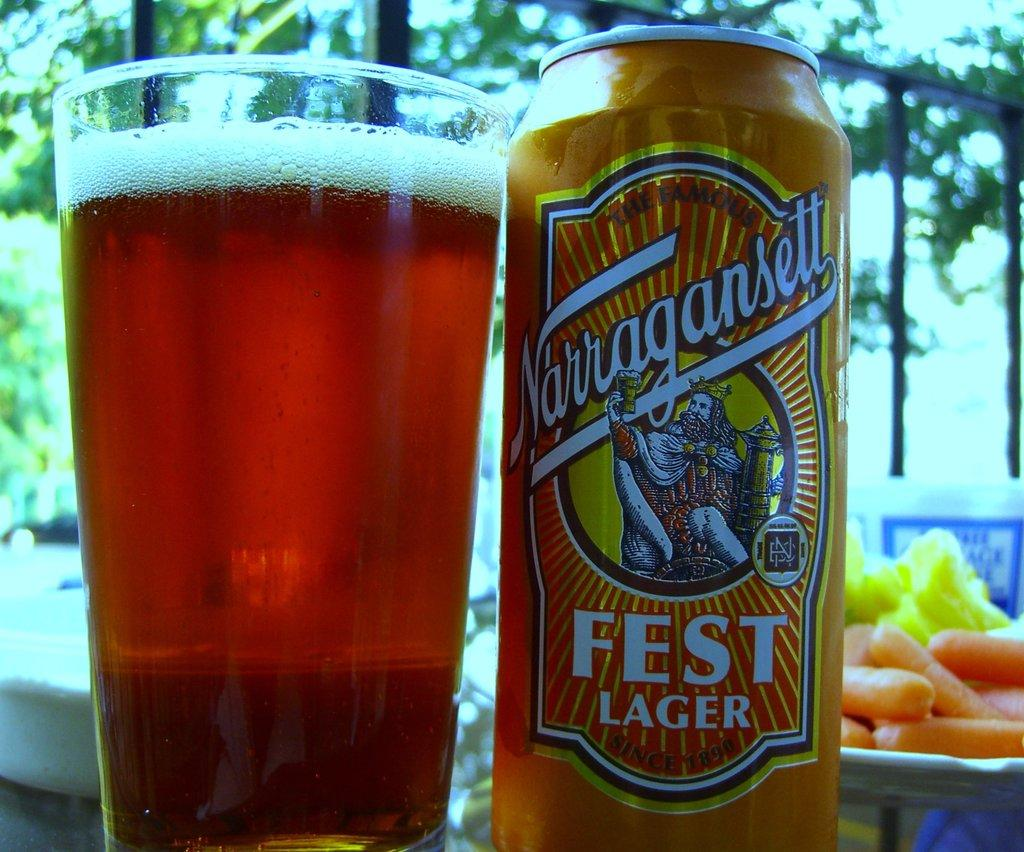<image>
Give a short and clear explanation of the subsequent image. A can of Fest Lager sitting next to a glass 